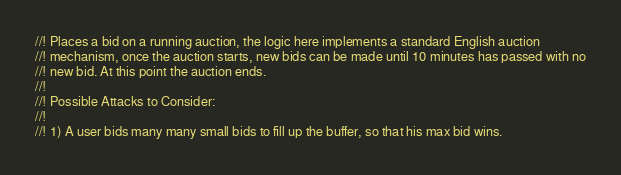Convert code to text. <code><loc_0><loc_0><loc_500><loc_500><_Rust_>//! Places a bid on a running auction, the logic here implements a standard English auction
//! mechanism, once the auction starts, new bids can be made until 10 minutes has passed with no
//! new bid. At this point the auction ends.
//!
//! Possible Attacks to Consider:
//!
//! 1) A user bids many many small bids to fill up the buffer, so that his max bid wins.</code> 